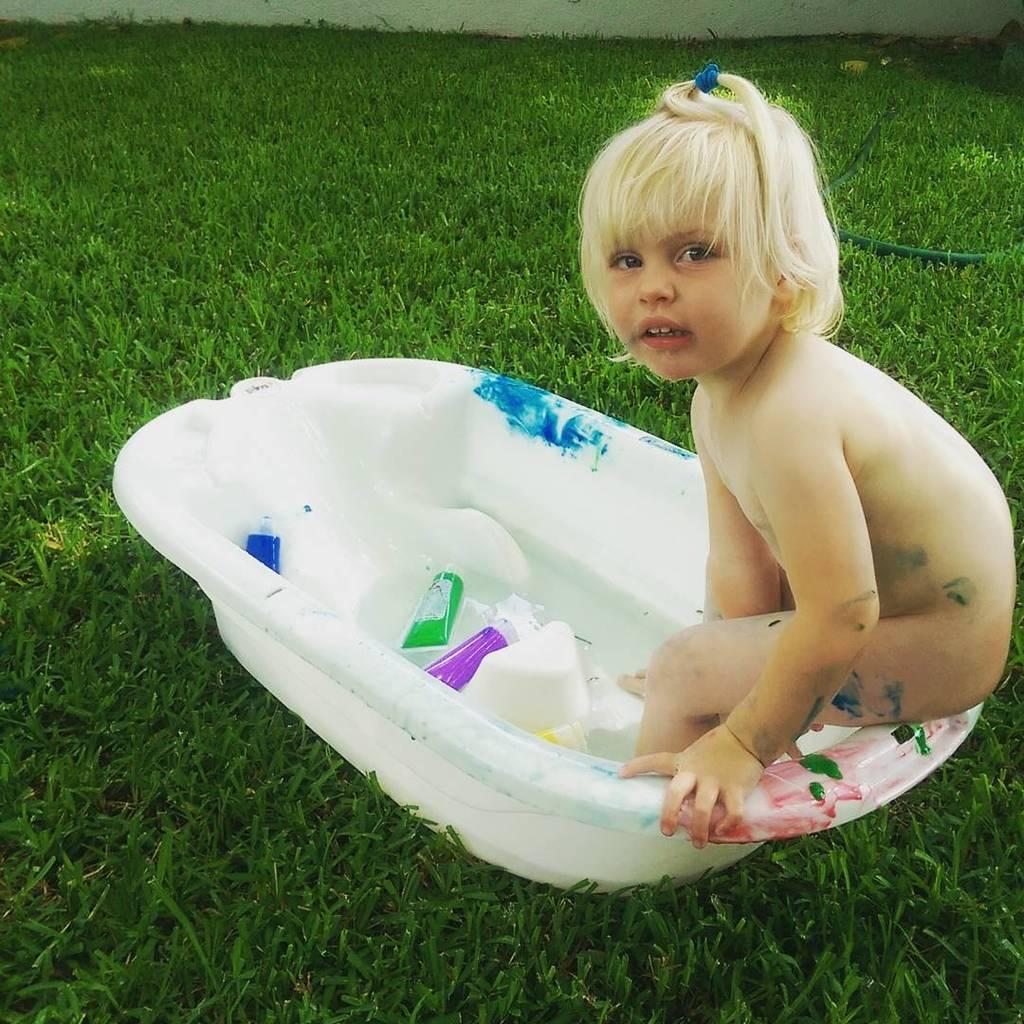What is the girl sitting in? The girl is sitting in a white tub. Where is the tub located? The tub is on grassy land. Can you describe any other objects in the image? There is a pipe visible, and there are two bottles in the tub. How many dolls are sitting next to the girl in the image? There are no dolls present in the image. What type of vase can be seen holding flowers in the image? There is no vase holding flowers in the image. 